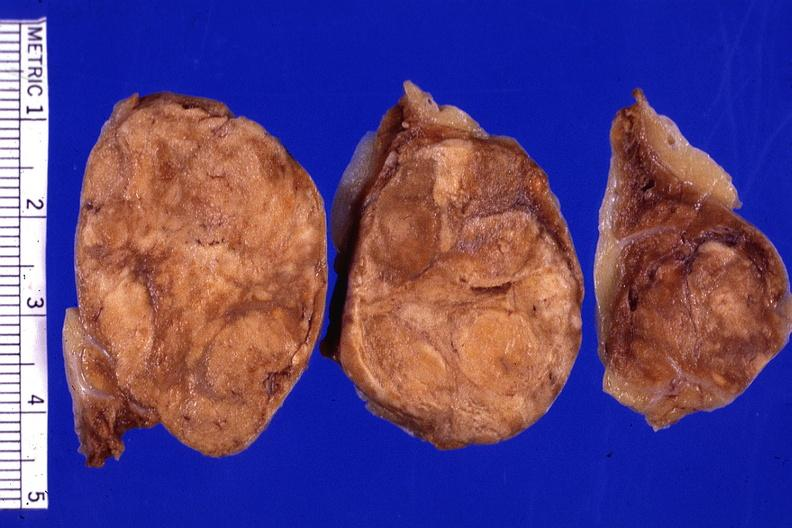what is present?
Answer the question using a single word or phrase. Endocrine 